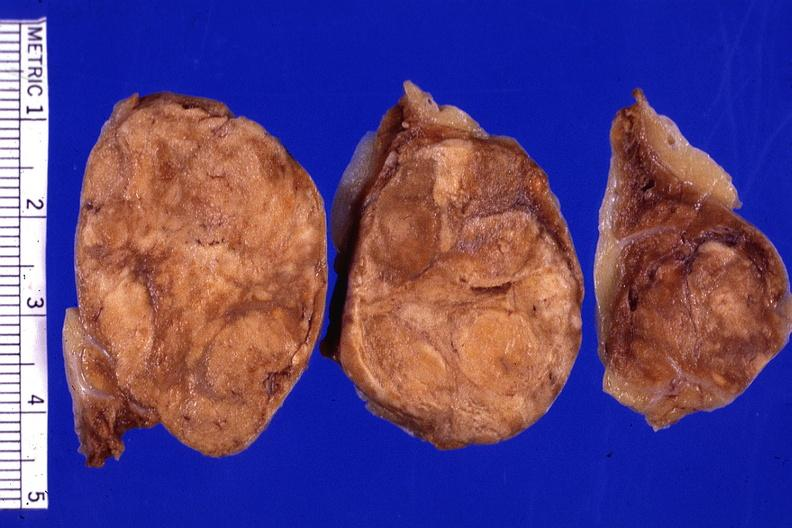what is present?
Answer the question using a single word or phrase. Endocrine 